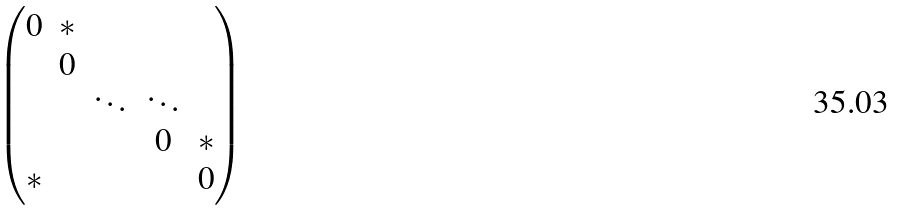<formula> <loc_0><loc_0><loc_500><loc_500>\begin{pmatrix} 0 & * & & & \\ & 0 & & & \\ & & \ddots & \ddots & \\ & & & 0 & * \\ * & & & & 0 \end{pmatrix}</formula> 